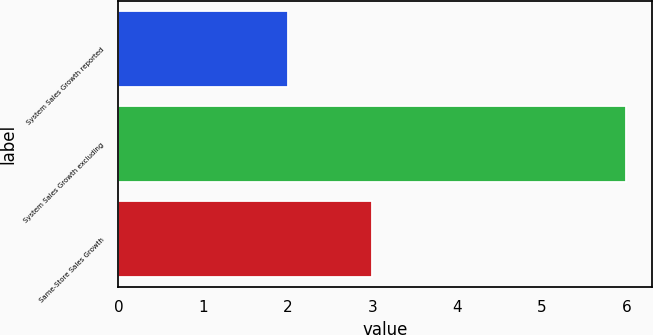<chart> <loc_0><loc_0><loc_500><loc_500><bar_chart><fcel>System Sales Growth reported<fcel>System Sales Growth excluding<fcel>Same-Store Sales Growth<nl><fcel>2<fcel>6<fcel>3<nl></chart> 